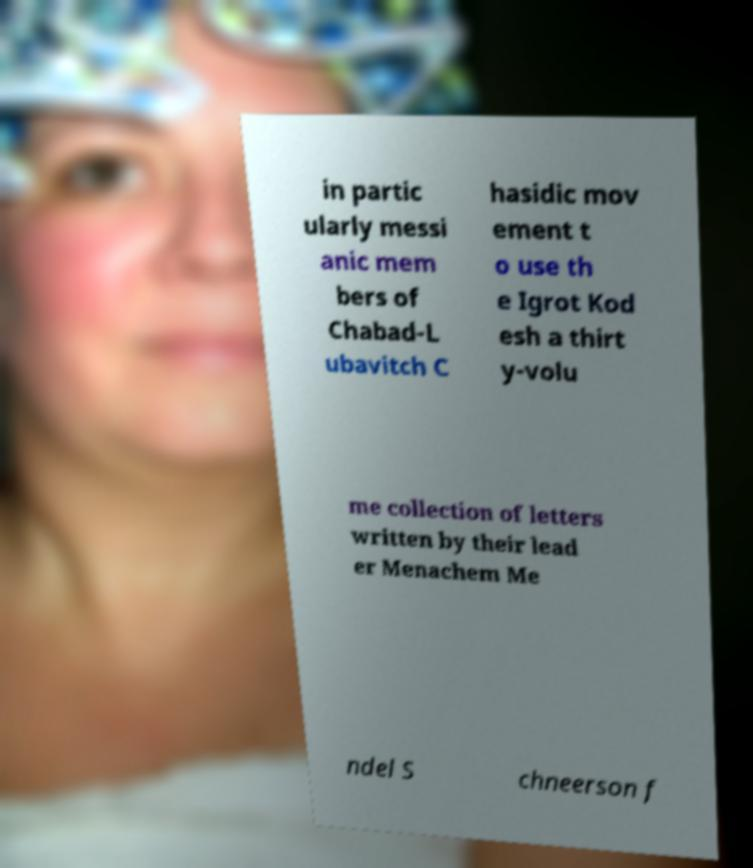Please identify and transcribe the text found in this image. in partic ularly messi anic mem bers of Chabad-L ubavitch C hasidic mov ement t o use th e Igrot Kod esh a thirt y-volu me collection of letters written by their lead er Menachem Me ndel S chneerson f 